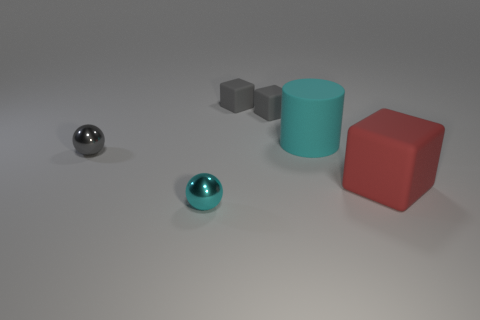The rubber object that is in front of the small gray thing in front of the rubber cylinder is what shape?
Ensure brevity in your answer.  Cube. What size is the shiny sphere in front of the sphere behind the metal object that is in front of the red object?
Your answer should be compact. Small. Is the cyan metallic ball the same size as the cyan matte thing?
Keep it short and to the point. No. What number of objects are tiny purple metallic balls or large things?
Provide a short and direct response. 2. What size is the metal ball on the right side of the shiny object behind the large cube?
Offer a terse response. Small. How big is the cyan shiny ball?
Make the answer very short. Small. There is a thing that is in front of the large rubber cylinder and right of the small cyan metal sphere; what is its shape?
Make the answer very short. Cube. There is another small object that is the same shape as the small cyan object; what color is it?
Keep it short and to the point. Gray. What number of things are objects right of the cyan metallic object or metal spheres that are behind the red thing?
Offer a very short reply. 5. The large cyan thing is what shape?
Make the answer very short. Cylinder. 